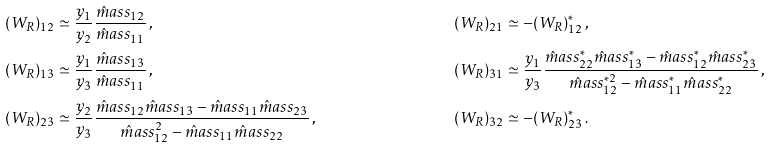<formula> <loc_0><loc_0><loc_500><loc_500>( W _ { R } ) _ { 1 2 } & \simeq \frac { y _ { 1 } } { y _ { 2 } } \frac { \hat { m } a s s _ { 1 2 } } { \hat { m } a s s _ { 1 1 } } \, , & ( W _ { R } ) _ { 2 1 } & \simeq - ( W _ { R } ) _ { 1 2 } ^ { * } \, , \\ ( W _ { R } ) _ { 1 3 } & \simeq \frac { y _ { 1 } } { y _ { 3 } } \frac { \hat { m } a s s _ { 1 3 } } { \hat { m } a s s _ { 1 1 } } \, , & ( W _ { R } ) _ { 3 1 } & \simeq \frac { y _ { 1 } } { y _ { 3 } } \frac { \hat { m } a s s _ { 2 2 } ^ { * } \hat { m } a s s _ { 1 3 } ^ { * } - \hat { m } a s s _ { 1 2 } ^ { * } \hat { m } a s s _ { 2 3 } ^ { * } } { \hat { m } a s s _ { 1 2 } ^ { * 2 } - \hat { m } a s s _ { 1 1 } ^ { * } \hat { m } a s s _ { 2 2 } ^ { * } } \, , \\ ( W _ { R } ) _ { 2 3 } & \simeq \frac { y _ { 2 } } { y _ { 3 } } \frac { \hat { m } a s s _ { 1 2 } \hat { m } a s s _ { 1 3 } - \hat { m } a s s _ { 1 1 } \hat { m } a s s _ { 2 3 } } { \hat { m } a s s _ { 1 2 } ^ { 2 } - \hat { m } a s s _ { 1 1 } \hat { m } a s s _ { 2 2 } } \, , & ( W _ { R } ) _ { 3 2 } & \simeq - ( W _ { R } ) _ { 2 3 } ^ { * } \, .</formula> 